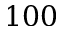<formula> <loc_0><loc_0><loc_500><loc_500>1 0 0</formula> 